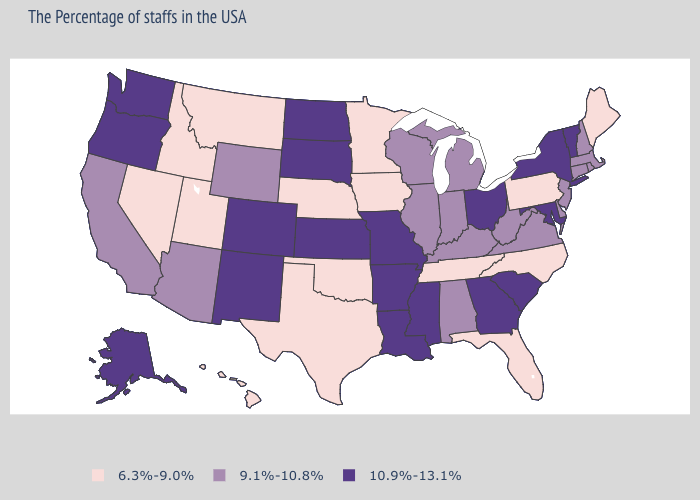Does Arkansas have the same value as North Dakota?
Give a very brief answer. Yes. What is the highest value in the USA?
Concise answer only. 10.9%-13.1%. What is the value of Oregon?
Concise answer only. 10.9%-13.1%. Which states have the lowest value in the South?
Concise answer only. North Carolina, Florida, Tennessee, Oklahoma, Texas. Does Tennessee have the lowest value in the USA?
Give a very brief answer. Yes. Does Arizona have the highest value in the USA?
Concise answer only. No. Which states have the lowest value in the USA?
Short answer required. Maine, Pennsylvania, North Carolina, Florida, Tennessee, Minnesota, Iowa, Nebraska, Oklahoma, Texas, Utah, Montana, Idaho, Nevada, Hawaii. What is the value of Kentucky?
Quick response, please. 9.1%-10.8%. What is the highest value in the USA?
Short answer required. 10.9%-13.1%. Which states have the lowest value in the West?
Short answer required. Utah, Montana, Idaho, Nevada, Hawaii. Does Washington have a lower value than Kentucky?
Answer briefly. No. Name the states that have a value in the range 6.3%-9.0%?
Answer briefly. Maine, Pennsylvania, North Carolina, Florida, Tennessee, Minnesota, Iowa, Nebraska, Oklahoma, Texas, Utah, Montana, Idaho, Nevada, Hawaii. What is the value of Hawaii?
Short answer required. 6.3%-9.0%. Name the states that have a value in the range 9.1%-10.8%?
Concise answer only. Massachusetts, Rhode Island, New Hampshire, Connecticut, New Jersey, Delaware, Virginia, West Virginia, Michigan, Kentucky, Indiana, Alabama, Wisconsin, Illinois, Wyoming, Arizona, California. Does Ohio have the highest value in the MidWest?
Keep it brief. Yes. 